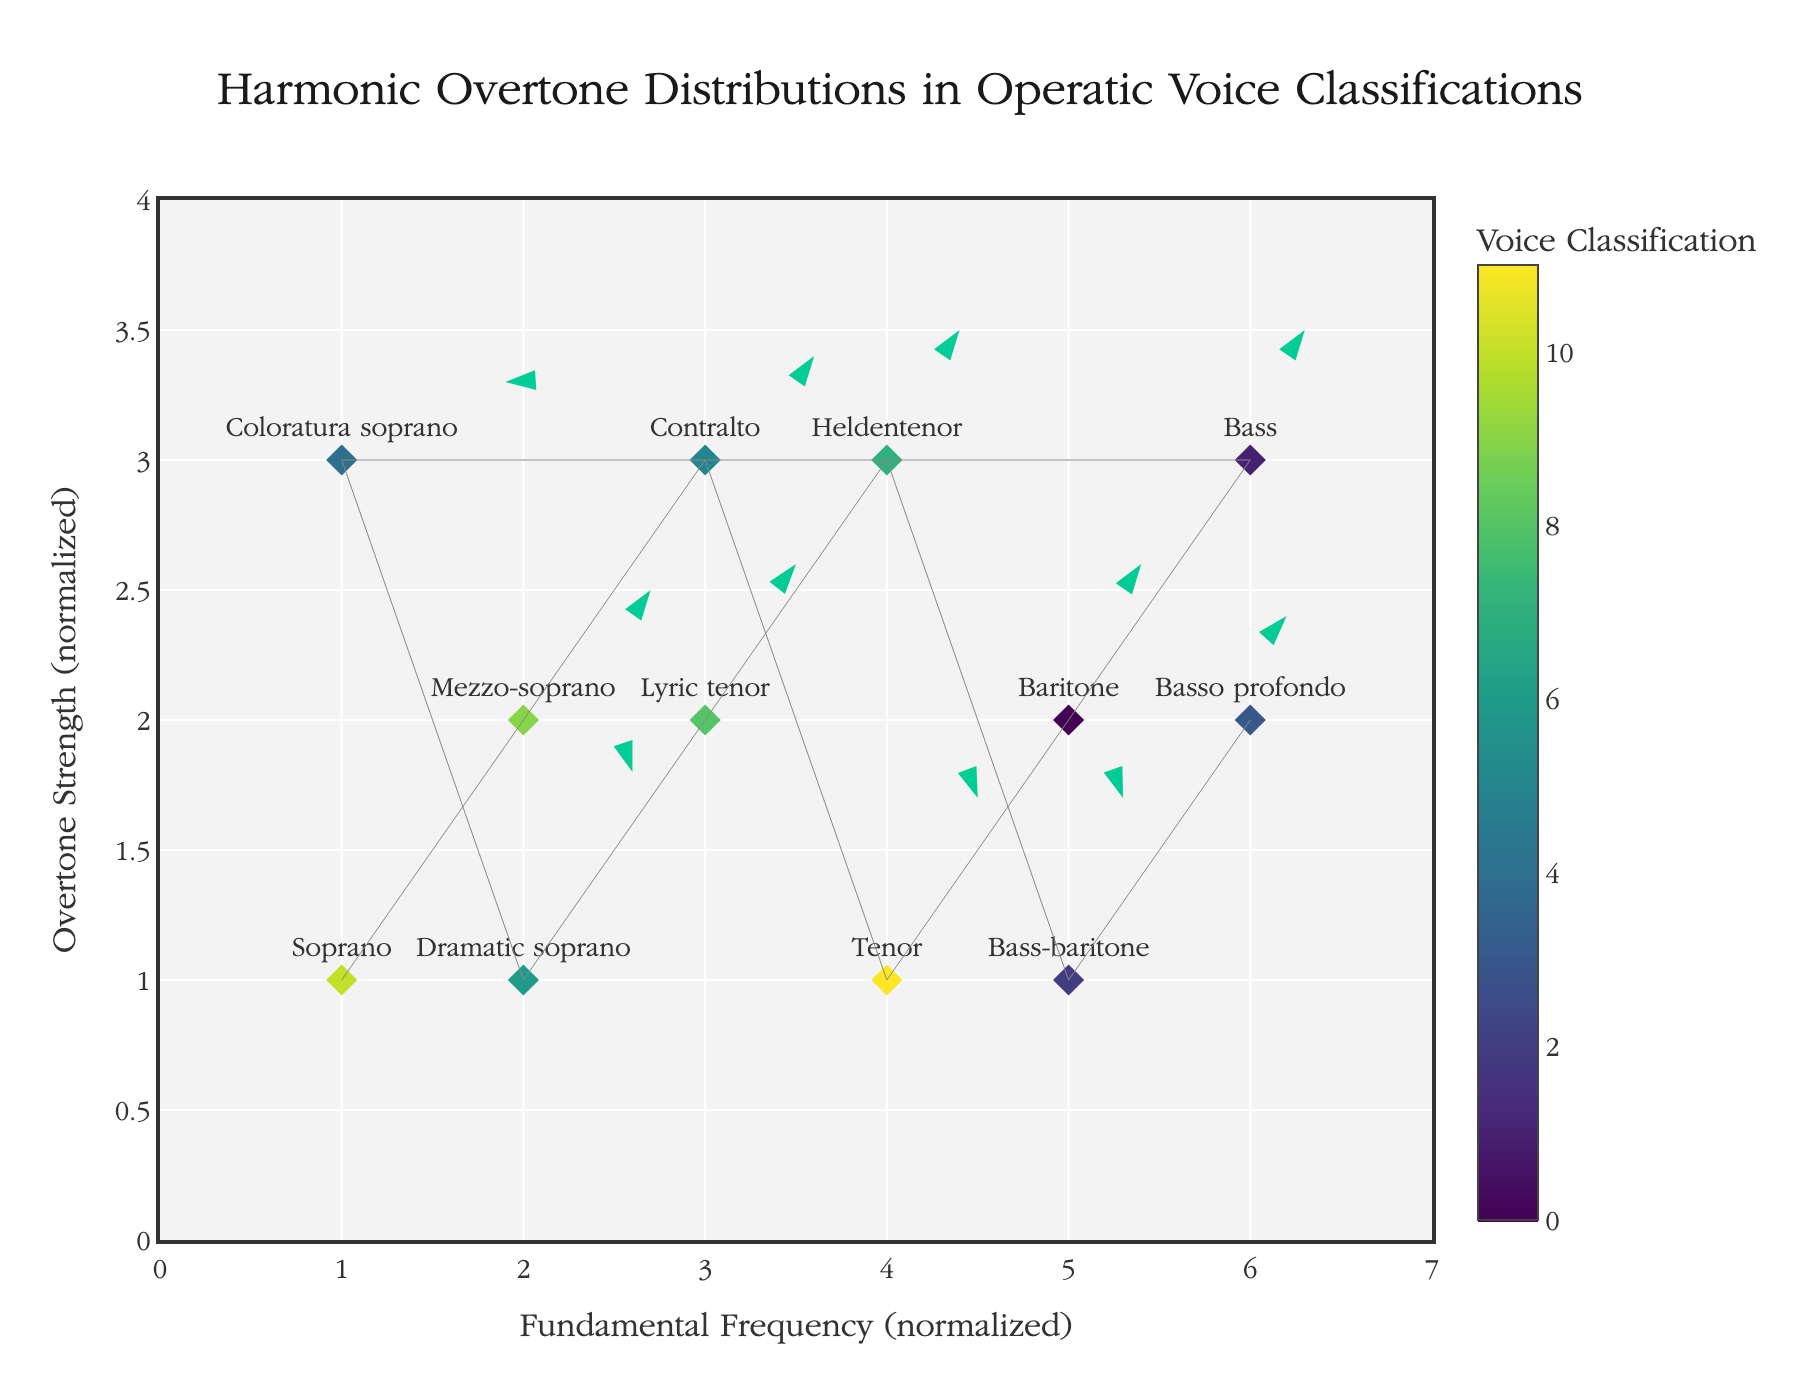What is the title of the plot? The title is located at the top of the plot and provides an overview of what the plot represents. The title reads: "Harmonic Overtone Distributions in Operatic Voice Classifications".
Answer: Harmonic Overtone Distributions in Operatic Voice Classifications How many different operatic voice classifications are represented in the plot? Each point in the plot is labeled with its corresponding voice classification. By counting the unique labels, we find there are twelve: Soprano, Mezzo-soprano, Contralto, Tenor, Baritone, Bass, Coloratura soprano, Dramatic soprano, Lyric tenor, Heldentenor, Bass-baritone, Basso profondo.
Answer: Twelve Which voice classification shows the highest overtone strength? The overtone strength is represented on the y-axis. The highest y value is 3, and it belongs to several classifications, including Coloratura soprano and Bass. However, if we look at the combination of x, y values and corresponding classifications, it is easiest to spot Coloratura soprano at (1,3).
Answer: Coloratura soprano Which voice classification's harmonic overtone distribution vector has the greatest vertical component? The vertical component of the vector is represented by the 'v' value. By comparing the 'v' values, the highest is 0.8 for Dramatic soprano.
Answer: Dramatic soprano What is the average overtone strength (Y value) of the classifications positioned at x=3? The voice classifications at x=3 are Contralto, Lyric tenor, and Basso profondo. Their y-values are 3, 2, and 2 respectively. The sum is 3+2+2=7. Dividing by the number of points (3), we get the average: 7/3 ≈ 2.33.
Answer: 2.33 Which voice classification has a vector that decreases in harmonic overtone strength? Vectors pointing downward have a negative vertical component 'v'. The Contralto classification at (3, 3) with a vector of u=0.6 and v=0.4 indicates a decrease because the endpoint lies below the starting point (2.6, 2.6).
Answer: Contralto Are there any classifications whose overtone strength increased by more than 0.5? An increase in overtone strength is represented by a positive vertical component 'v'. The classifications with v>0.5 are Soprano, Tenor, Baritone, Dramatic soprano, and Bass-baritone.
Answer: Yes Which classification is closest to having a perfect horizontal harmonic overtone distribution vector (i.e., no change in overtone strength)? A horizontal vector would have a 'v' value close to 0. The classification closest to this is Coloratura soprano with v=0.3.
Answer: Coloratura soprano What is the sum of the vertical components (v-values) for Bass and Basso profondo classifications? The 'v' values for Bass and Basso profondo are 0.5 and 0.4, respectively. The sum of these values is 0.5 + 0.4 = 0.9.
Answer: 0.9 